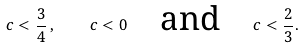<formula> <loc_0><loc_0><loc_500><loc_500>c < \frac { 3 } { 4 } \, , \quad c < 0 \quad \text {and} \quad c < \frac { 2 } { 3 } .</formula> 